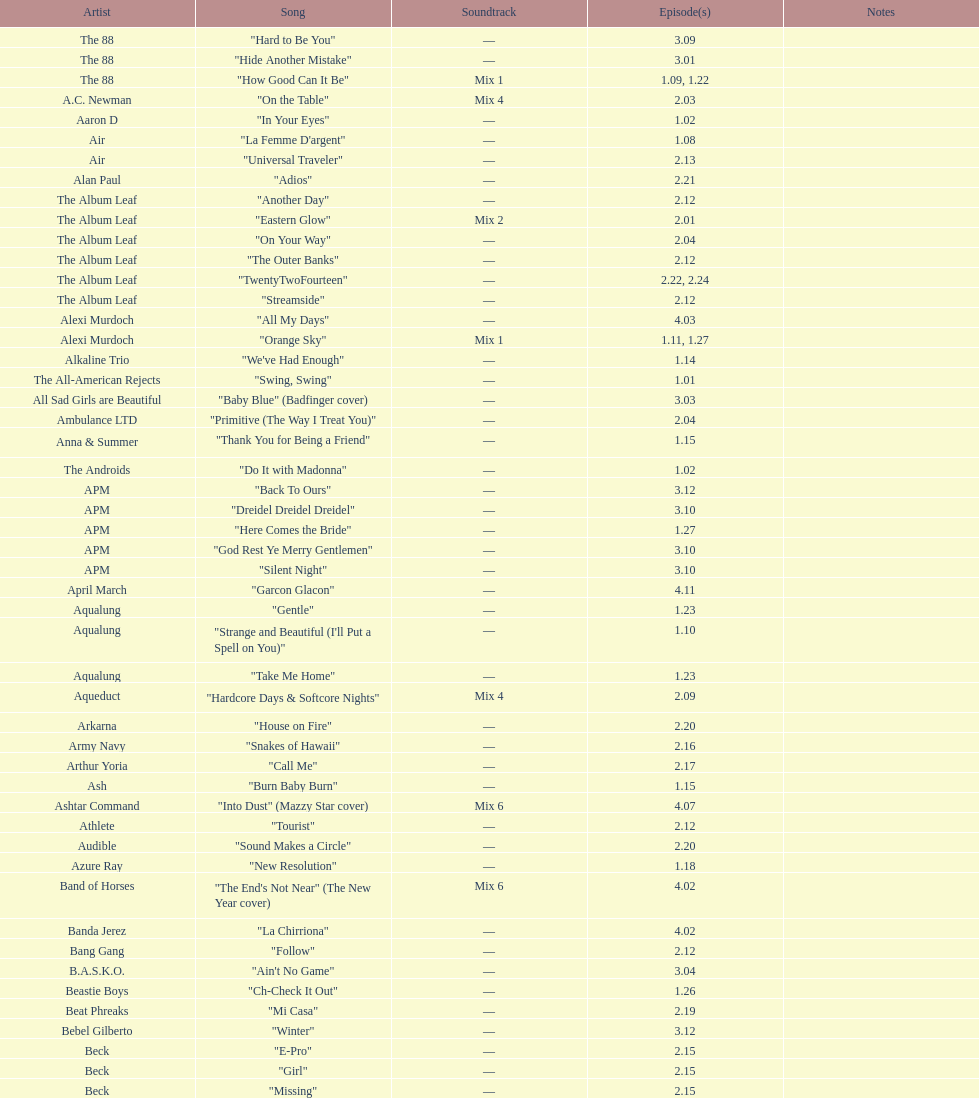What is the number of successive tracks by the album leaf? 6. 